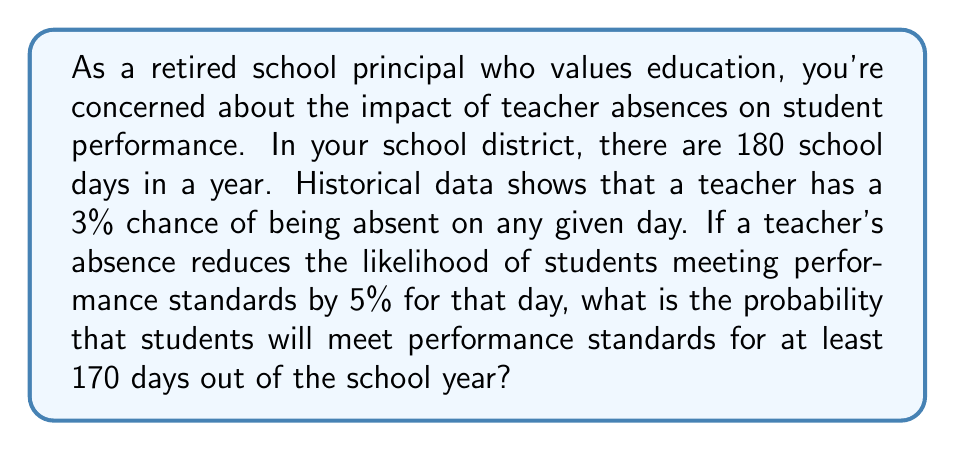Show me your answer to this math problem. Let's approach this step-by-step:

1) First, we need to calculate the probability of a teacher being present on any given day:
   $P(\text{present}) = 1 - P(\text{absent}) = 1 - 0.03 = 0.97$

2) When the teacher is present, the students have a 100% chance of meeting performance standards. When the teacher is absent, this reduces to 95%.

3) So, the probability of students meeting performance standards on any given day is:
   $P(\text{meet standards}) = (0.97 \times 1) + (0.03 \times 0.95) = 0.97 + 0.0285 = 0.9985$

4) Now, we need to find the probability of meeting standards on at least 170 out of 180 days. This is a binomial probability problem.

5) We can calculate this using the cumulative binomial probability:

   $$P(X \geq 170) = \sum_{k=170}^{180} \binom{180}{k} (0.9985)^k (0.0015)^{180-k}$$

6) This can be calculated using the complementary event:

   $$P(X \geq 170) = 1 - P(X < 170) = 1 - P(X \leq 169)$$

7) Using a binomial probability calculator or a spreadsheet function (as this involves a large number of calculations), we find:

   $$P(X \geq 170) \approx 0.9999$$
Answer: The probability that students will meet performance standards for at least 170 days out of the 180-day school year is approximately 0.9999 or 99.99%. 